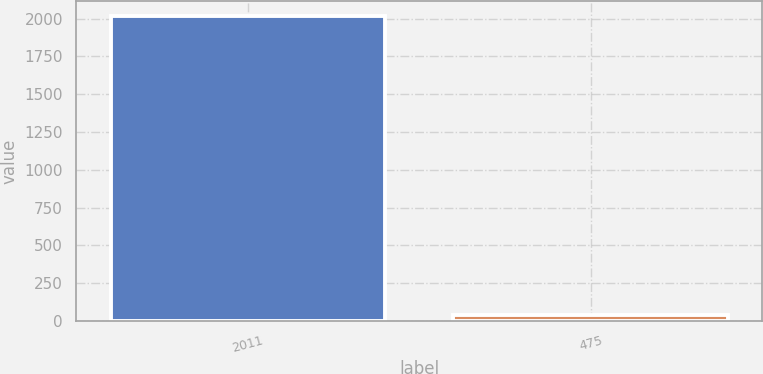<chart> <loc_0><loc_0><loc_500><loc_500><bar_chart><fcel>2011<fcel>475<nl><fcel>2014<fcel>36.4<nl></chart> 